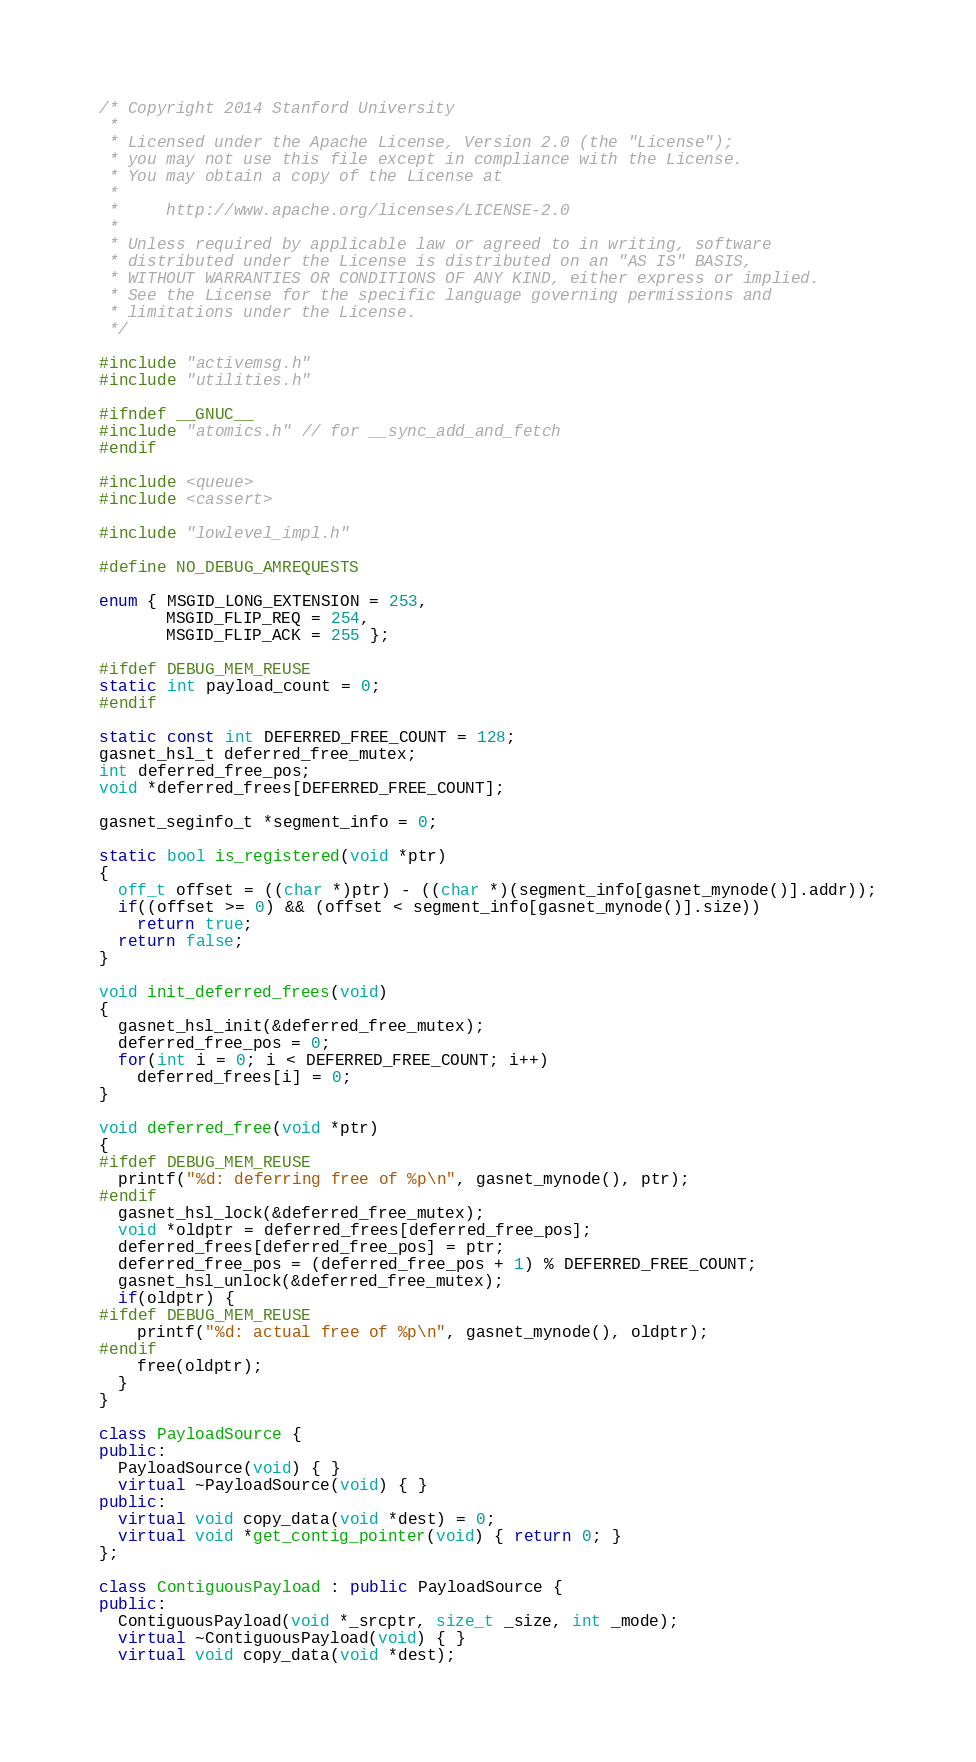<code> <loc_0><loc_0><loc_500><loc_500><_C++_>/* Copyright 2014 Stanford University
 *
 * Licensed under the Apache License, Version 2.0 (the "License");
 * you may not use this file except in compliance with the License.
 * You may obtain a copy of the License at
 *
 *     http://www.apache.org/licenses/LICENSE-2.0
 *
 * Unless required by applicable law or agreed to in writing, software
 * distributed under the License is distributed on an "AS IS" BASIS,
 * WITHOUT WARRANTIES OR CONDITIONS OF ANY KIND, either express or implied.
 * See the License for the specific language governing permissions and
 * limitations under the License.
 */

#include "activemsg.h"
#include "utilities.h"

#ifndef __GNUC__
#include "atomics.h" // for __sync_add_and_fetch
#endif

#include <queue>
#include <cassert>

#include "lowlevel_impl.h"

#define NO_DEBUG_AMREQUESTS

enum { MSGID_LONG_EXTENSION = 253,
       MSGID_FLIP_REQ = 254,
       MSGID_FLIP_ACK = 255 };

#ifdef DEBUG_MEM_REUSE
static int payload_count = 0;
#endif

static const int DEFERRED_FREE_COUNT = 128;
gasnet_hsl_t deferred_free_mutex;
int deferred_free_pos;
void *deferred_frees[DEFERRED_FREE_COUNT];

gasnet_seginfo_t *segment_info = 0;

static bool is_registered(void *ptr)
{
  off_t offset = ((char *)ptr) - ((char *)(segment_info[gasnet_mynode()].addr));
  if((offset >= 0) && (offset < segment_info[gasnet_mynode()].size))
    return true;
  return false;
}

void init_deferred_frees(void)
{
  gasnet_hsl_init(&deferred_free_mutex);
  deferred_free_pos = 0;
  for(int i = 0; i < DEFERRED_FREE_COUNT; i++)
    deferred_frees[i] = 0;
}

void deferred_free(void *ptr)
{
#ifdef DEBUG_MEM_REUSE
  printf("%d: deferring free of %p\n", gasnet_mynode(), ptr);
#endif
  gasnet_hsl_lock(&deferred_free_mutex);
  void *oldptr = deferred_frees[deferred_free_pos];
  deferred_frees[deferred_free_pos] = ptr;
  deferred_free_pos = (deferred_free_pos + 1) % DEFERRED_FREE_COUNT;
  gasnet_hsl_unlock(&deferred_free_mutex);
  if(oldptr) {
#ifdef DEBUG_MEM_REUSE
    printf("%d: actual free of %p\n", gasnet_mynode(), oldptr);
#endif
    free(oldptr);
  }
}

class PayloadSource {
public:
  PayloadSource(void) { }
  virtual ~PayloadSource(void) { }
public:
  virtual void copy_data(void *dest) = 0;
  virtual void *get_contig_pointer(void) { return 0; }
};

class ContiguousPayload : public PayloadSource {
public:
  ContiguousPayload(void *_srcptr, size_t _size, int _mode);
  virtual ~ContiguousPayload(void) { }
  virtual void copy_data(void *dest);</code> 